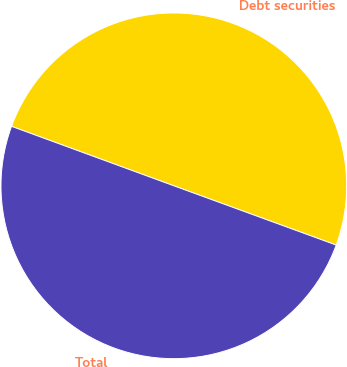Convert chart to OTSL. <chart><loc_0><loc_0><loc_500><loc_500><pie_chart><fcel>Debt securities<fcel>Total<nl><fcel>49.98%<fcel>50.02%<nl></chart> 